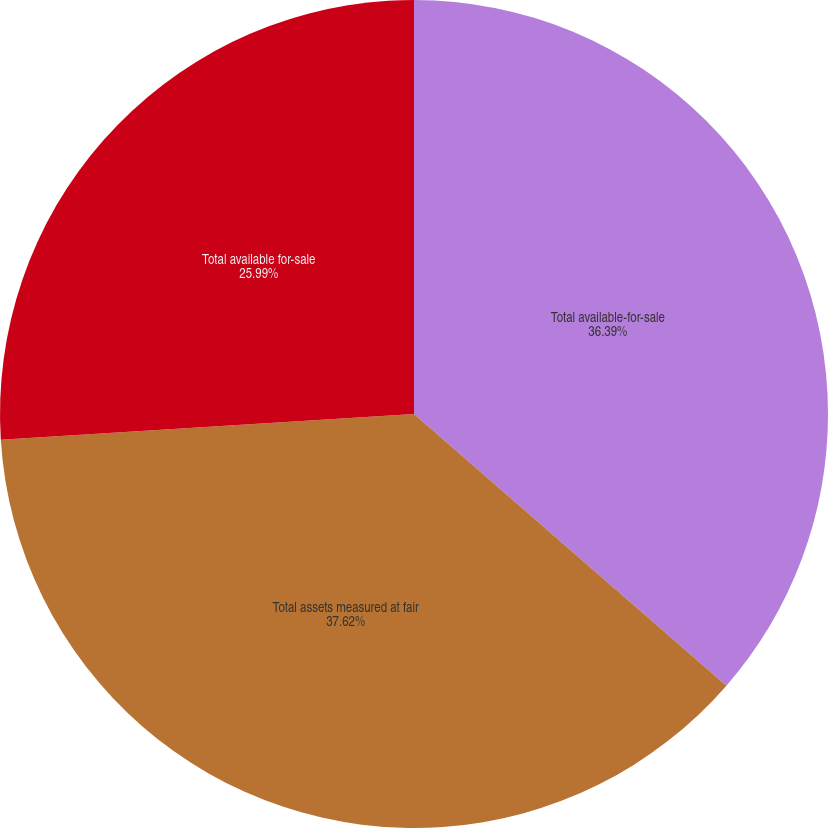<chart> <loc_0><loc_0><loc_500><loc_500><pie_chart><fcel>Total available-for-sale<fcel>Total assets measured at fair<fcel>Total available for-sale<nl><fcel>36.39%<fcel>37.62%<fcel>25.99%<nl></chart> 